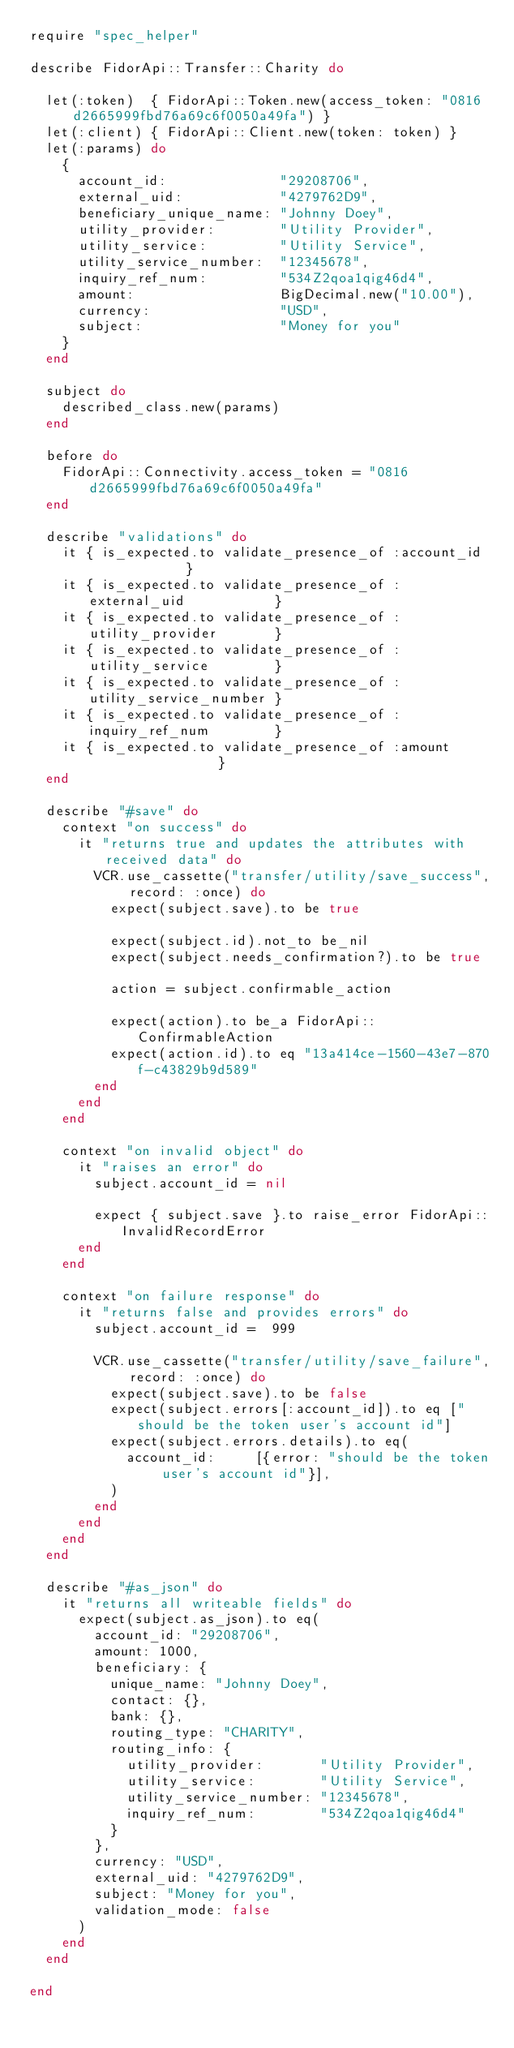<code> <loc_0><loc_0><loc_500><loc_500><_Ruby_>require "spec_helper"

describe FidorApi::Transfer::Charity do

  let(:token)  { FidorApi::Token.new(access_token: "0816d2665999fbd76a69c6f0050a49fa") }
  let(:client) { FidorApi::Client.new(token: token) }
  let(:params) do
    {
      account_id:              "29208706",
      external_uid:            "4279762D9",
      beneficiary_unique_name: "Johnny Doey",
      utility_provider:        "Utility Provider",
      utility_service:         "Utility Service",
      utility_service_number:  "12345678",
      inquiry_ref_num:         "534Z2qoa1qig46d4",
      amount:                  BigDecimal.new("10.00"),
      currency:                "USD",
      subject:                 "Money for you"
    }
  end

  subject do
    described_class.new(params)
  end

  before do
    FidorApi::Connectivity.access_token = "0816d2665999fbd76a69c6f0050a49fa"
  end

  describe "validations" do
    it { is_expected.to validate_presence_of :account_id             }
    it { is_expected.to validate_presence_of :external_uid           }
    it { is_expected.to validate_presence_of :utility_provider       }
    it { is_expected.to validate_presence_of :utility_service        }
    it { is_expected.to validate_presence_of :utility_service_number }
    it { is_expected.to validate_presence_of :inquiry_ref_num        }
    it { is_expected.to validate_presence_of :amount                 }
  end

  describe "#save" do
    context "on success" do
      it "returns true and updates the attributes with received data" do
        VCR.use_cassette("transfer/utility/save_success", record: :once) do
          expect(subject.save).to be true

          expect(subject.id).not_to be_nil
          expect(subject.needs_confirmation?).to be true

          action = subject.confirmable_action

          expect(action).to be_a FidorApi::ConfirmableAction
          expect(action.id).to eq "13a414ce-1560-43e7-870f-c43829b9d589"
        end
      end
    end

    context "on invalid object" do
      it "raises an error" do
        subject.account_id = nil

        expect { subject.save }.to raise_error FidorApi::InvalidRecordError
      end
    end

    context "on failure response" do
      it "returns false and provides errors" do
        subject.account_id =  999

        VCR.use_cassette("transfer/utility/save_failure", record: :once) do
          expect(subject.save).to be false
          expect(subject.errors[:account_id]).to eq ["should be the token user's account id"]
          expect(subject.errors.details).to eq(
            account_id:     [{error: "should be the token user's account id"}],
          )
        end
      end
    end
  end

  describe "#as_json" do
    it "returns all writeable fields" do
      expect(subject.as_json).to eq(
        account_id: "29208706",
        amount: 1000,
        beneficiary: {
          unique_name: "Johnny Doey",
          contact: {},
          bank: {},
          routing_type: "CHARITY",
          routing_info: {
            utility_provider:       "Utility Provider",
            utility_service:        "Utility Service",
            utility_service_number: "12345678",
            inquiry_ref_num:        "534Z2qoa1qig46d4"
          }
        },
        currency: "USD",
        external_uid: "4279762D9",
        subject: "Money for you",
        validation_mode: false
      )
    end
  end

end
</code> 